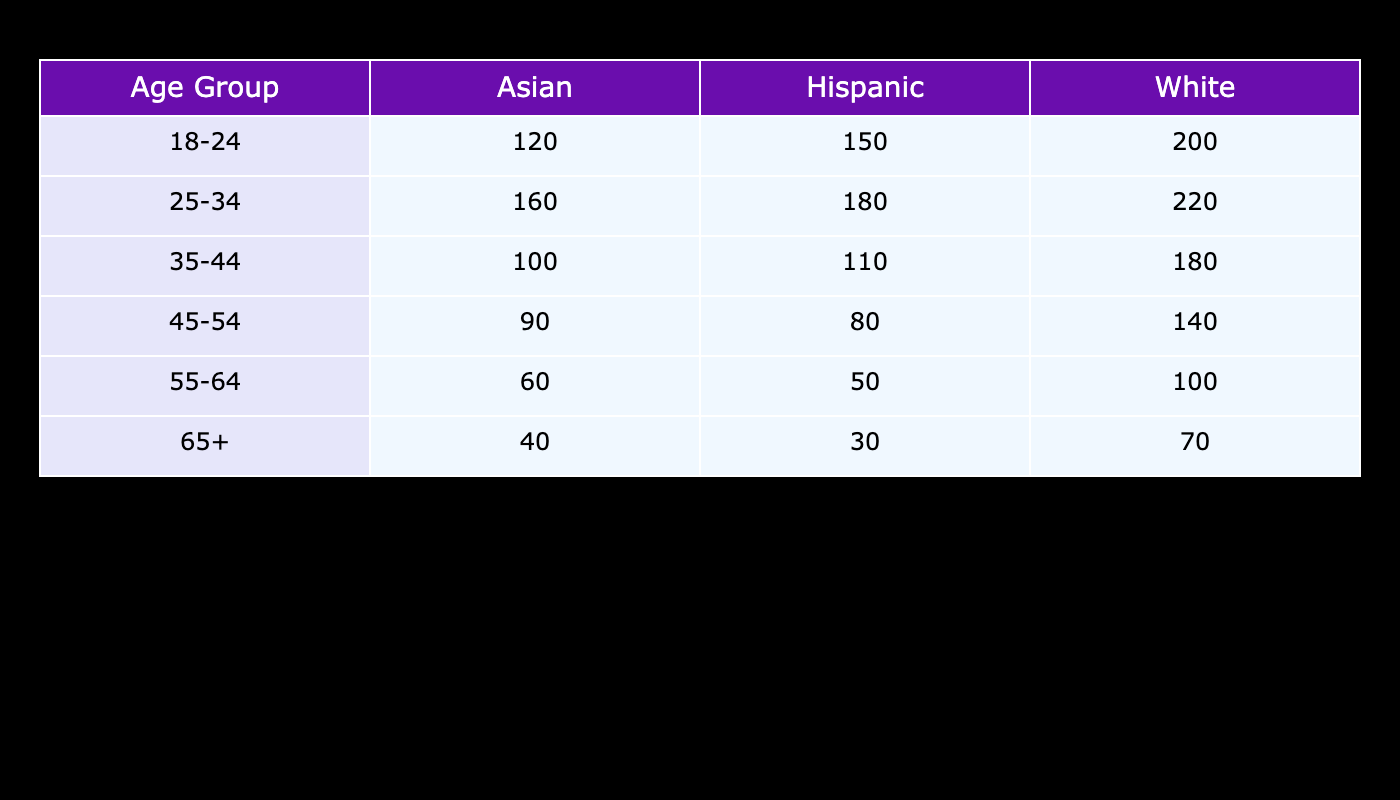What is the total attendance of the Hispanic cultural background across all age groups? To find the total attendance for the Hispanic group, I sum the values from the Hispanic row for each age group: 150 (18-24) + 180 (25-34) + 110 (35-44) + 80 (45-54) + 50 (55-64) + 30 (65+) = 600.
Answer: 600 Which age group has the highest attendance for the Asian cultural background? The Asian cultural background has the following attendance figures: 120 (18-24), 160 (25-34), 100 (35-44), 90 (45-54), 60 (55-64), and 40 (65+). The highest of these is 160, which corresponds to the 25-34 age group.
Answer: 25-34 Is the total attendance for the White cultural background greater than 1,000 across all age groups? I sum the White attendance figures: 200 (18-24) + 220 (25-34) + 180 (35-44) + 140 (45-54) + 100 (55-64) + 70 (65+) = 1,000. Since the total equals 1,000, the statement is false.
Answer: No What is the average attendance for the 35-44 age group across all cultural backgrounds? For the 35-44 age group, the attendance figures are: 110 (Hispanic) + 100 (Asian) + 180 (White). First, I add these numbers: 110 + 100 + 180 = 390. There are 3 data points, so I divide: 390/3 = 130.
Answer: 130 How does the attendance of the 18-24 age group compare to the 65+ age group for the White cultural background? For the White cultural background, the 18-24 age group has an attendance of 200, while the 65+ age group has 70. The difference is 200 - 70 = 130, indicating that the 18-24 age group has significantly higher attendance.
Answer: 130 more 